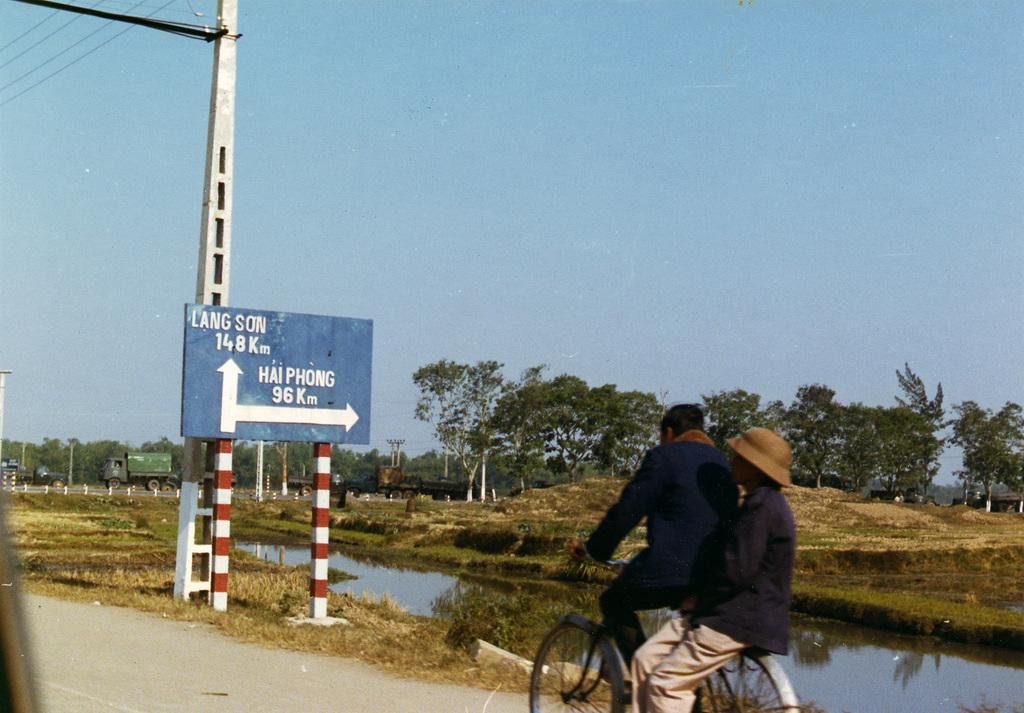What is the main subject of the image? The main subject of the image is a man riding a bicycle with another person sitting at the back. What can be seen in the background of the image? There is a sign board, a pole, wires, the sky, trees, and a lane of water visible in the background. What is the position of the second person in the image? The second person is sitting at the back of the man on the bicycle. What type of scarecrow can be seen in the image? There is no scarecrow present in the image. What religious symbol can be seen in the image? There is no religious symbol present in the image. 